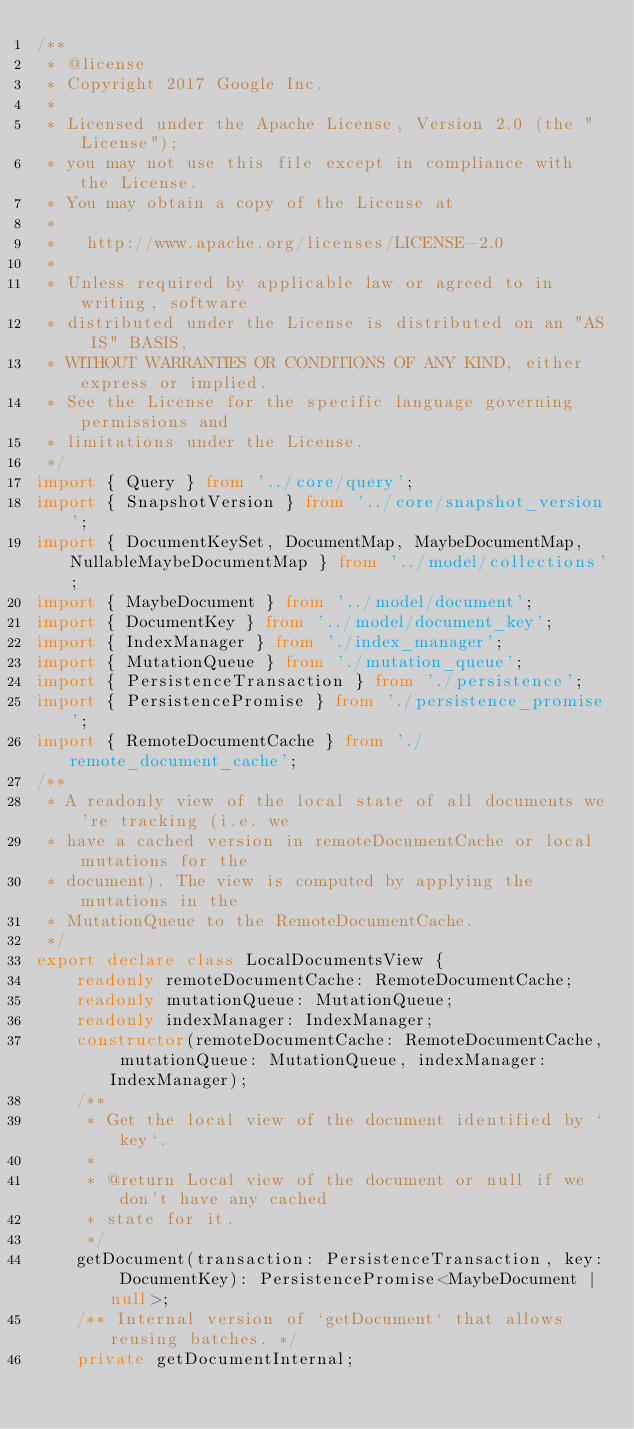Convert code to text. <code><loc_0><loc_0><loc_500><loc_500><_TypeScript_>/**
 * @license
 * Copyright 2017 Google Inc.
 *
 * Licensed under the Apache License, Version 2.0 (the "License");
 * you may not use this file except in compliance with the License.
 * You may obtain a copy of the License at
 *
 *   http://www.apache.org/licenses/LICENSE-2.0
 *
 * Unless required by applicable law or agreed to in writing, software
 * distributed under the License is distributed on an "AS IS" BASIS,
 * WITHOUT WARRANTIES OR CONDITIONS OF ANY KIND, either express or implied.
 * See the License for the specific language governing permissions and
 * limitations under the License.
 */
import { Query } from '../core/query';
import { SnapshotVersion } from '../core/snapshot_version';
import { DocumentKeySet, DocumentMap, MaybeDocumentMap, NullableMaybeDocumentMap } from '../model/collections';
import { MaybeDocument } from '../model/document';
import { DocumentKey } from '../model/document_key';
import { IndexManager } from './index_manager';
import { MutationQueue } from './mutation_queue';
import { PersistenceTransaction } from './persistence';
import { PersistencePromise } from './persistence_promise';
import { RemoteDocumentCache } from './remote_document_cache';
/**
 * A readonly view of the local state of all documents we're tracking (i.e. we
 * have a cached version in remoteDocumentCache or local mutations for the
 * document). The view is computed by applying the mutations in the
 * MutationQueue to the RemoteDocumentCache.
 */
export declare class LocalDocumentsView {
    readonly remoteDocumentCache: RemoteDocumentCache;
    readonly mutationQueue: MutationQueue;
    readonly indexManager: IndexManager;
    constructor(remoteDocumentCache: RemoteDocumentCache, mutationQueue: MutationQueue, indexManager: IndexManager);
    /**
     * Get the local view of the document identified by `key`.
     *
     * @return Local view of the document or null if we don't have any cached
     * state for it.
     */
    getDocument(transaction: PersistenceTransaction, key: DocumentKey): PersistencePromise<MaybeDocument | null>;
    /** Internal version of `getDocument` that allows reusing batches. */
    private getDocumentInternal;</code> 